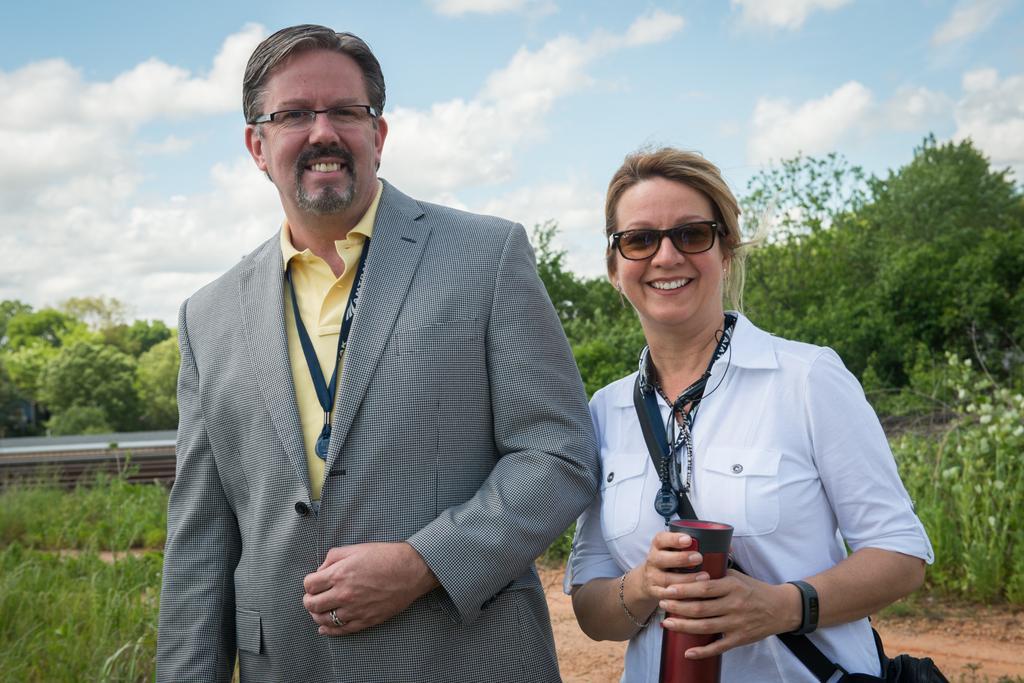Could you give a brief overview of what you see in this image? In this picture we can see a man standing and smiling. We can see a woman wearing a bag and holding a bottle in her hand. She is standing and smiling. We can see some grass and plants on the ground. There are a few trees visible in the background. Sky is blue in color and cloudy. 